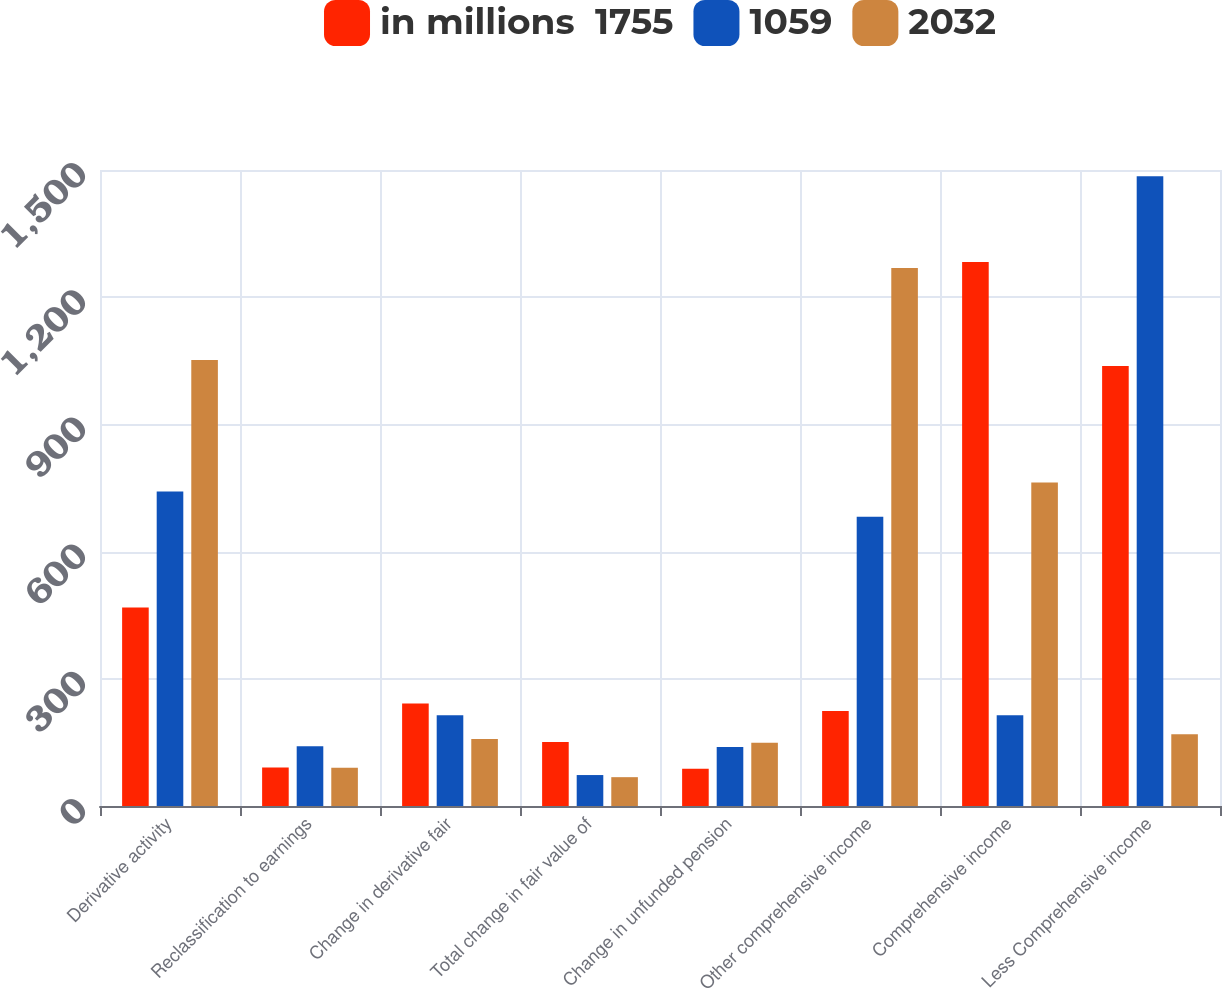Convert chart. <chart><loc_0><loc_0><loc_500><loc_500><stacked_bar_chart><ecel><fcel>Derivative activity<fcel>Reclassification to earnings<fcel>Change in derivative fair<fcel>Total change in fair value of<fcel>Change in unfunded pension<fcel>Other comprehensive income<fcel>Comprehensive income<fcel>Less Comprehensive income<nl><fcel>in millions  1755<fcel>468<fcel>91<fcel>242<fcel>151<fcel>88<fcel>224<fcel>1283<fcel>1038<nl><fcel>1059<fcel>742<fcel>141<fcel>214<fcel>73<fcel>139<fcel>682<fcel>214<fcel>1485<nl><fcel>2032<fcel>1052<fcel>90<fcel>158<fcel>68<fcel>149<fcel>1269<fcel>763<fcel>169<nl></chart> 